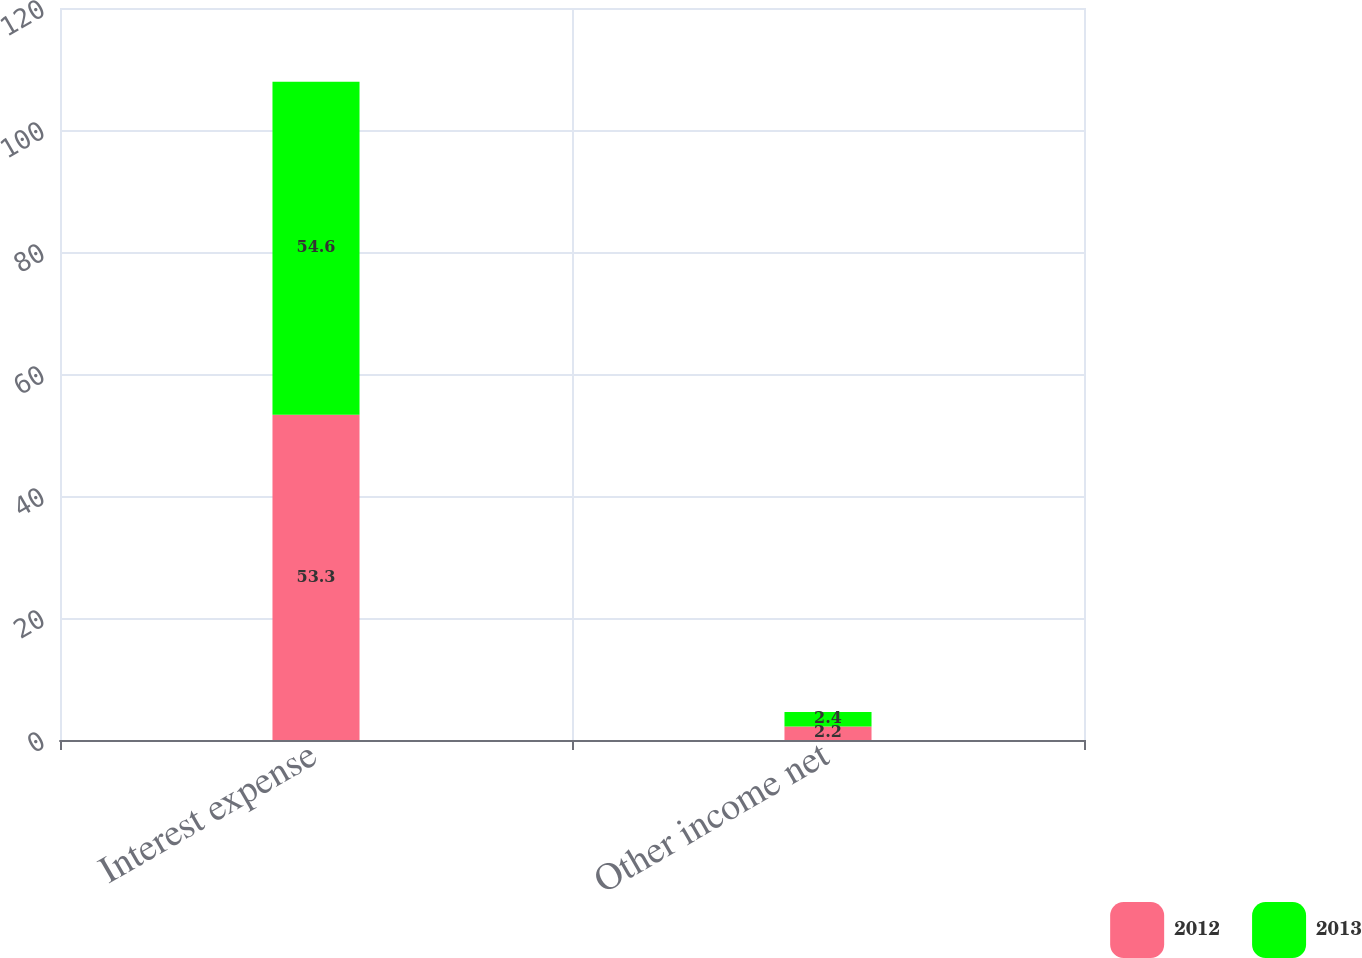Convert chart. <chart><loc_0><loc_0><loc_500><loc_500><stacked_bar_chart><ecel><fcel>Interest expense<fcel>Other income net<nl><fcel>2012<fcel>53.3<fcel>2.2<nl><fcel>2013<fcel>54.6<fcel>2.4<nl></chart> 